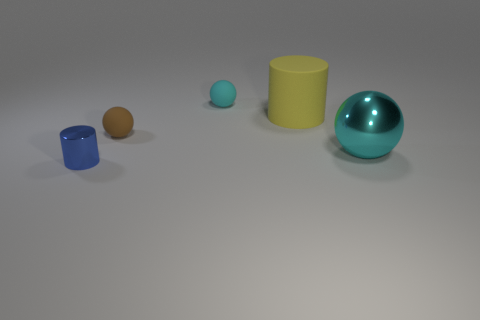Add 4 large red rubber blocks. How many objects exist? 9 Subtract all spheres. How many objects are left? 2 Subtract all small gray objects. Subtract all spheres. How many objects are left? 2 Add 5 small brown balls. How many small brown balls are left? 6 Add 1 red metal blocks. How many red metal blocks exist? 1 Subtract 2 cyan spheres. How many objects are left? 3 